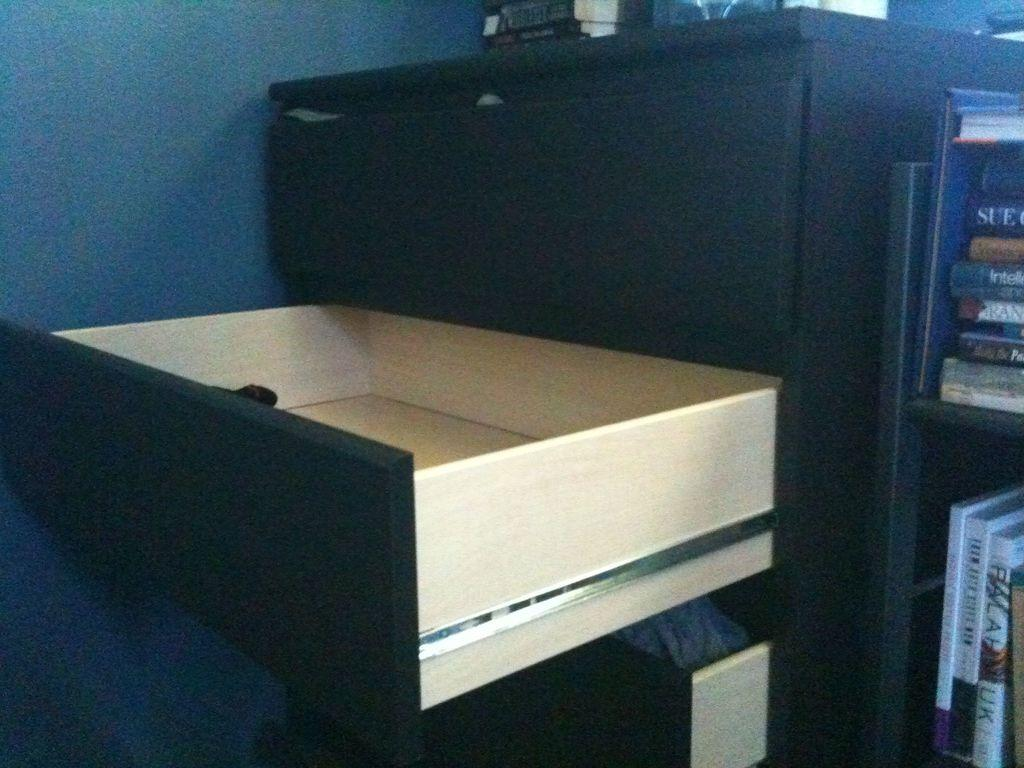What type of furniture is present in the image? There is a cupboard with drawers in the image. What is placed on the cupboard? There are books on the cupboard. Are there any other cupboards in the image? Yes, there is another cupboard with books in the image. What is visible on the left side of the image? There is a wall on the left side of the image. Can you tell me how many friends are helping with the eggnog in the image? There is no eggnog or friends present in the image; it features cupboards and books. 